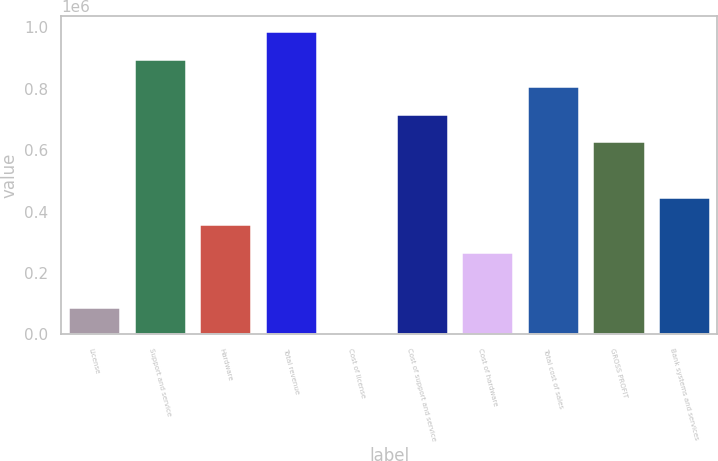Convert chart to OTSL. <chart><loc_0><loc_0><loc_500><loc_500><bar_chart><fcel>License<fcel>Support and service<fcel>Hardware<fcel>Total revenue<fcel>Cost of license<fcel>Cost of support and service<fcel>Cost of hardware<fcel>Total cost of sales<fcel>GROSS PROFIT<fcel>Bank systems and services<nl><fcel>90266.6<fcel>897671<fcel>359401<fcel>987383<fcel>555<fcel>718248<fcel>269690<fcel>807959<fcel>628536<fcel>449113<nl></chart> 